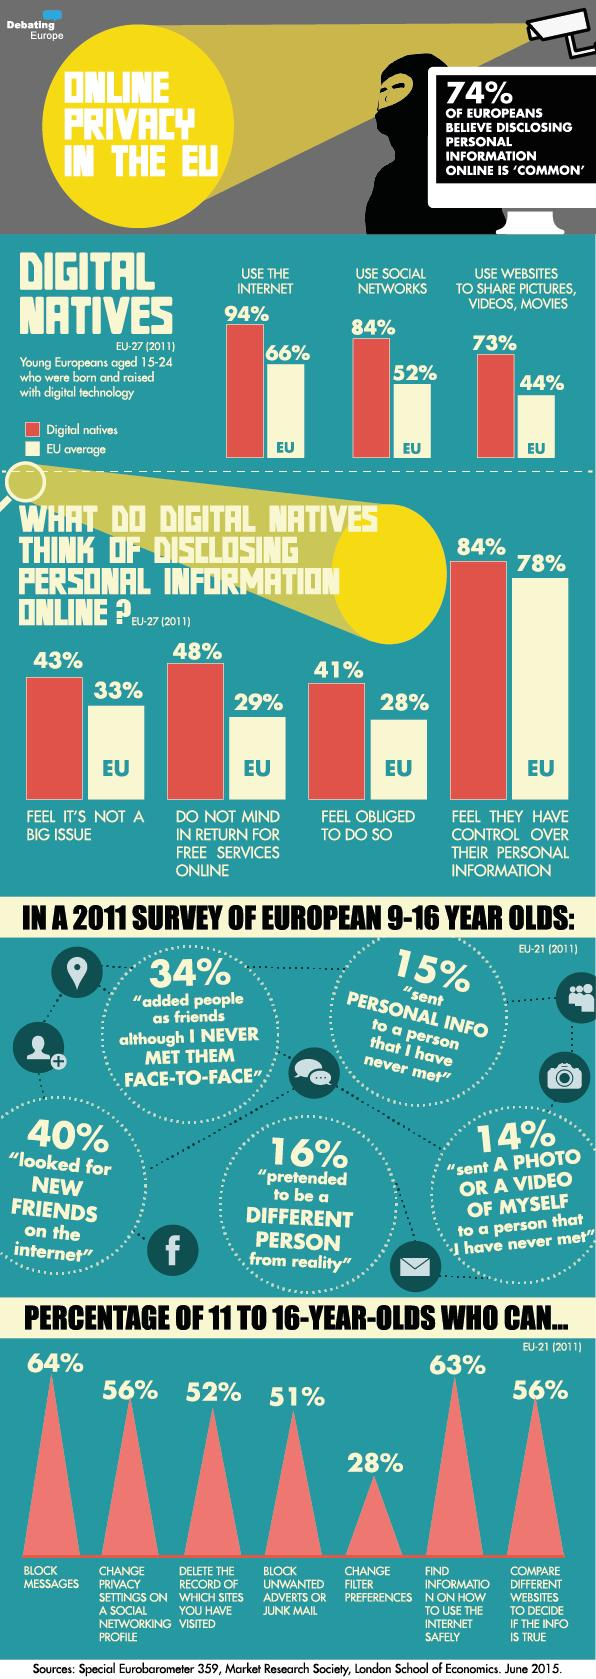Indicate a few pertinent items in this graphic. According to a recent survey, 29% of people in the EU are willing to disclose personal information for free online services. According to a study, 94% of digital natives use the internet. According to a recent study, it was found that 84% of digital natives use social networks. A survey found that 51% of 11-16 year olds are able to block unwanted ads or junk mail. According to a recent survey, 44% of people in the EU use websites to share pictures, videos, and other digital content. 